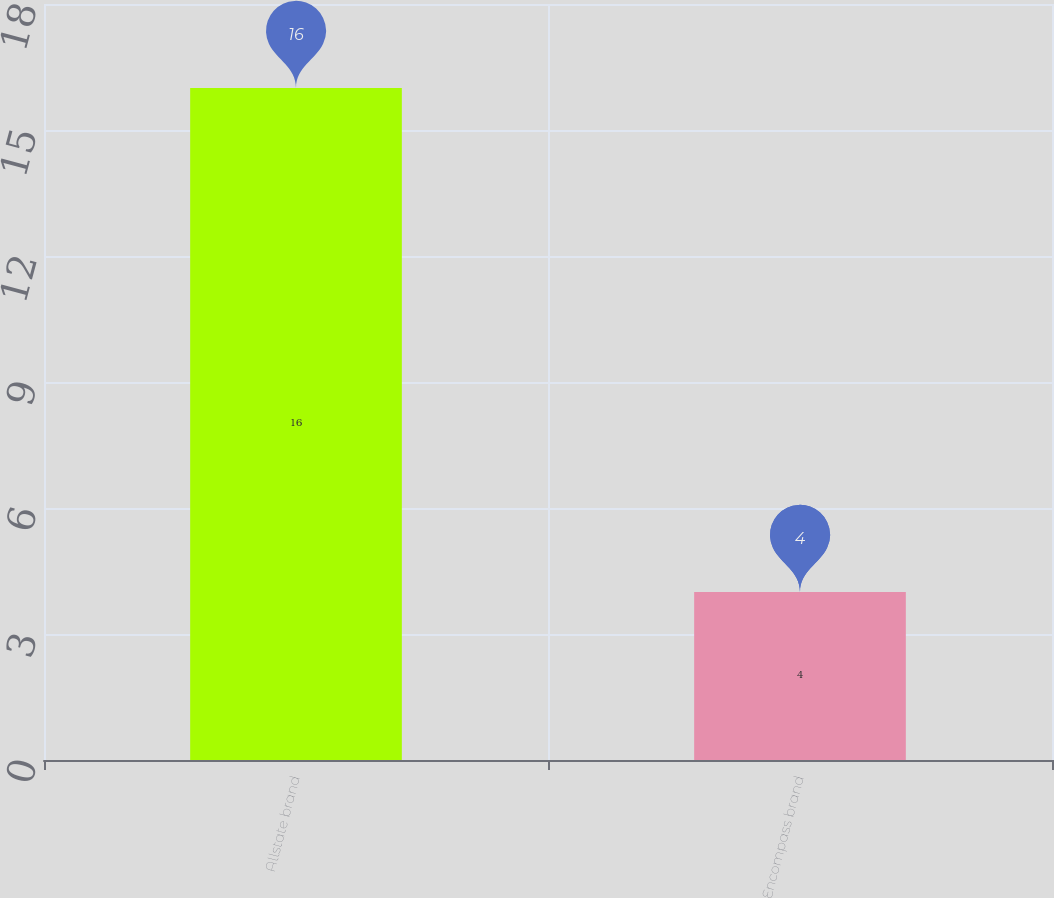Convert chart. <chart><loc_0><loc_0><loc_500><loc_500><bar_chart><fcel>Allstate brand<fcel>Encompass brand<nl><fcel>16<fcel>4<nl></chart> 